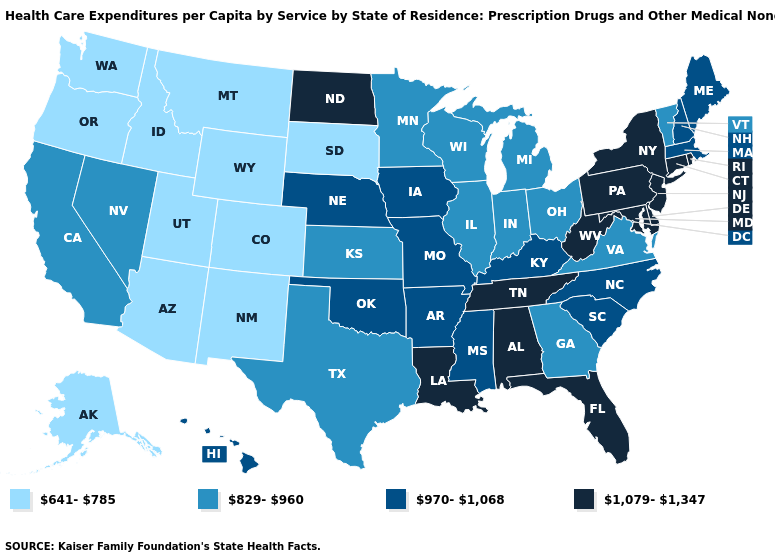What is the lowest value in the USA?
Quick response, please. 641-785. Is the legend a continuous bar?
Keep it brief. No. What is the highest value in the West ?
Write a very short answer. 970-1,068. Does Missouri have a lower value than Delaware?
Concise answer only. Yes. What is the value of Missouri?
Write a very short answer. 970-1,068. Which states have the highest value in the USA?
Quick response, please. Alabama, Connecticut, Delaware, Florida, Louisiana, Maryland, New Jersey, New York, North Dakota, Pennsylvania, Rhode Island, Tennessee, West Virginia. Does Utah have the lowest value in the USA?
Answer briefly. Yes. What is the highest value in the USA?
Give a very brief answer. 1,079-1,347. What is the highest value in states that border Oregon?
Concise answer only. 829-960. What is the value of North Dakota?
Short answer required. 1,079-1,347. Name the states that have a value in the range 641-785?
Give a very brief answer. Alaska, Arizona, Colorado, Idaho, Montana, New Mexico, Oregon, South Dakota, Utah, Washington, Wyoming. Name the states that have a value in the range 641-785?
Concise answer only. Alaska, Arizona, Colorado, Idaho, Montana, New Mexico, Oregon, South Dakota, Utah, Washington, Wyoming. Is the legend a continuous bar?
Write a very short answer. No. What is the lowest value in states that border Connecticut?
Answer briefly. 970-1,068. Does the first symbol in the legend represent the smallest category?
Short answer required. Yes. 